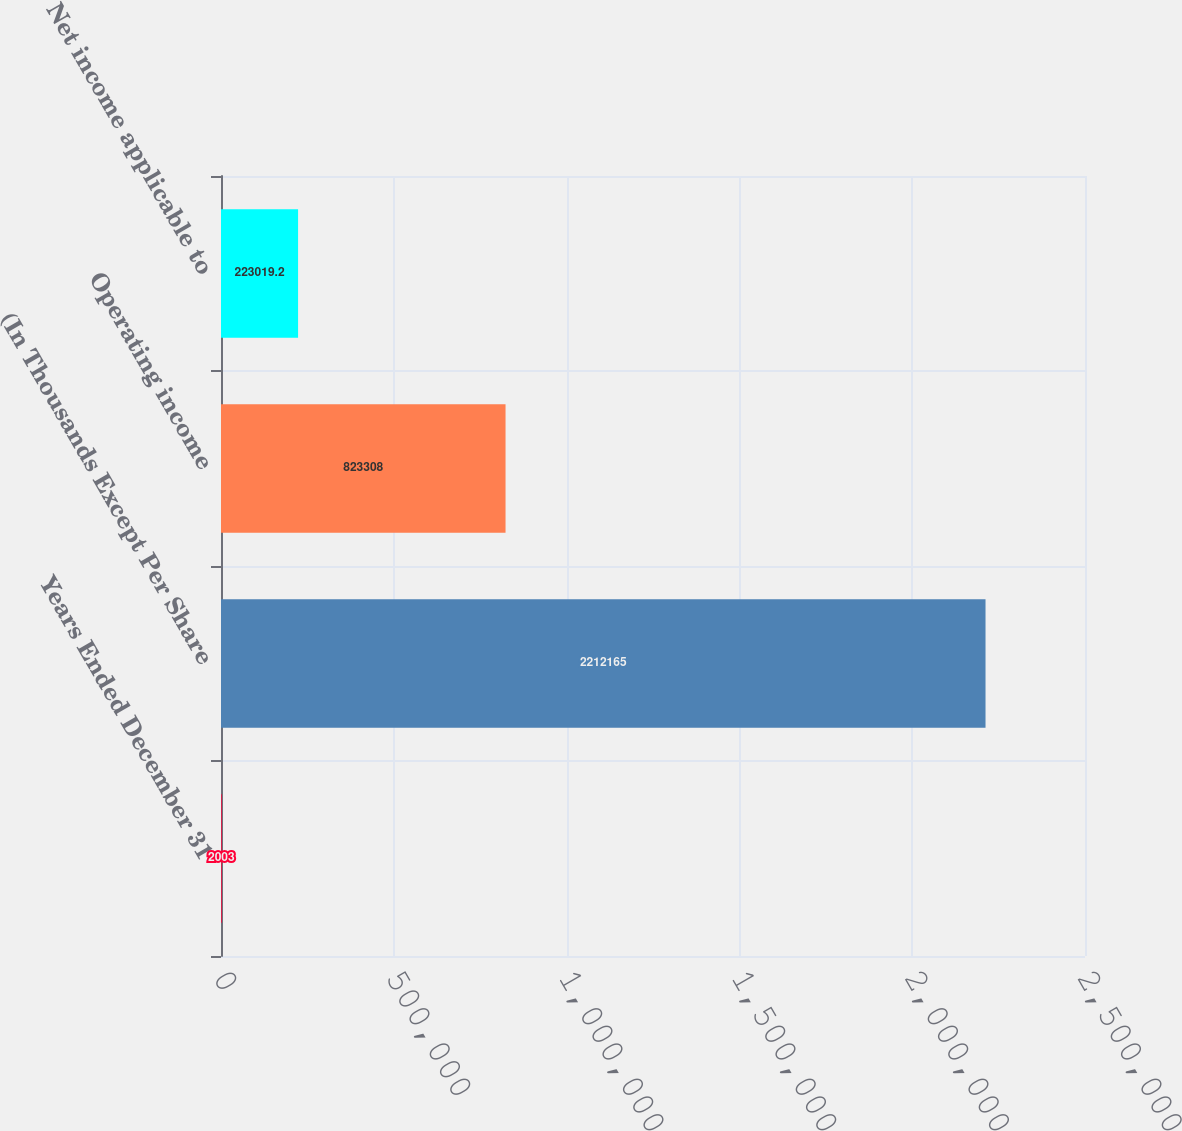Convert chart to OTSL. <chart><loc_0><loc_0><loc_500><loc_500><bar_chart><fcel>Years Ended December 31<fcel>(In Thousands Except Per Share<fcel>Operating income<fcel>Net income applicable to<nl><fcel>2003<fcel>2.21216e+06<fcel>823308<fcel>223019<nl></chart> 